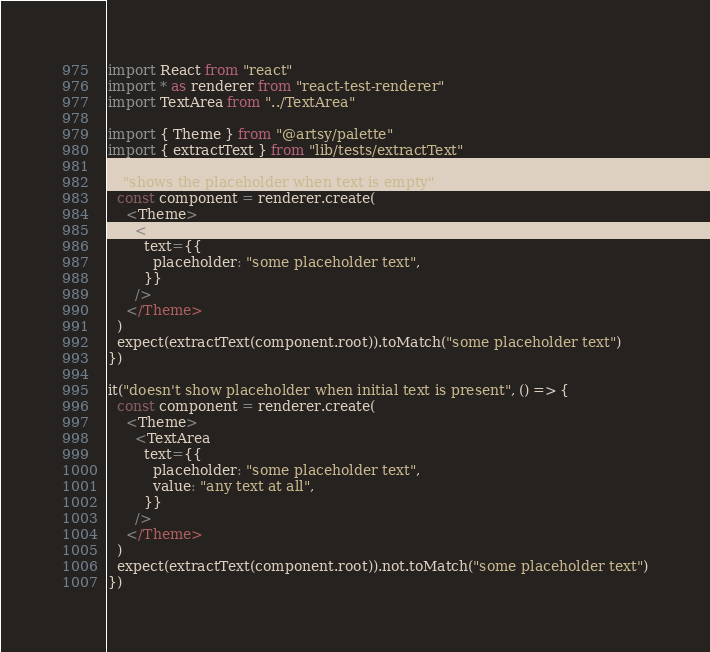Convert code to text. <code><loc_0><loc_0><loc_500><loc_500><_TypeScript_>import React from "react"
import * as renderer from "react-test-renderer"
import TextArea from "../TextArea"

import { Theme } from "@artsy/palette"
import { extractText } from "lib/tests/extractText"

it("shows the placeholder when text is empty", () => {
  const component = renderer.create(
    <Theme>
      <TextArea
        text={{
          placeholder: "some placeholder text",
        }}
      />
    </Theme>
  )
  expect(extractText(component.root)).toMatch("some placeholder text")
})

it("doesn't show placeholder when initial text is present", () => {
  const component = renderer.create(
    <Theme>
      <TextArea
        text={{
          placeholder: "some placeholder text",
          value: "any text at all",
        }}
      />
    </Theme>
  )
  expect(extractText(component.root)).not.toMatch("some placeholder text")
})
</code> 